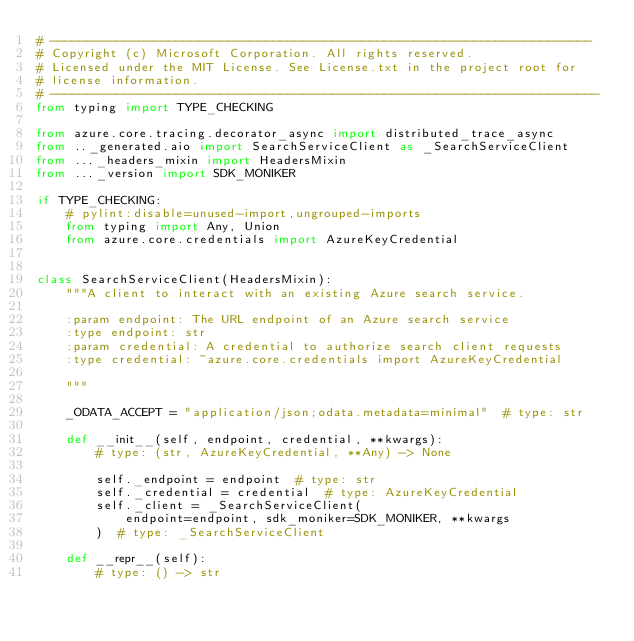<code> <loc_0><loc_0><loc_500><loc_500><_Python_># -------------------------------------------------------------------------
# Copyright (c) Microsoft Corporation. All rights reserved.
# Licensed under the MIT License. See License.txt in the project root for
# license information.
# --------------------------------------------------------------------------
from typing import TYPE_CHECKING

from azure.core.tracing.decorator_async import distributed_trace_async
from .._generated.aio import SearchServiceClient as _SearchServiceClient
from ..._headers_mixin import HeadersMixin
from ..._version import SDK_MONIKER

if TYPE_CHECKING:
    # pylint:disable=unused-import,ungrouped-imports
    from typing import Any, Union
    from azure.core.credentials import AzureKeyCredential


class SearchServiceClient(HeadersMixin):
    """A client to interact with an existing Azure search service.

    :param endpoint: The URL endpoint of an Azure search service
    :type endpoint: str
    :param credential: A credential to authorize search client requests
    :type credential: ~azure.core.credentials import AzureKeyCredential

    """

    _ODATA_ACCEPT = "application/json;odata.metadata=minimal"  # type: str

    def __init__(self, endpoint, credential, **kwargs):
        # type: (str, AzureKeyCredential, **Any) -> None

        self._endpoint = endpoint  # type: str
        self._credential = credential  # type: AzureKeyCredential
        self._client = _SearchServiceClient(
            endpoint=endpoint, sdk_moniker=SDK_MONIKER, **kwargs
        )  # type: _SearchServiceClient

    def __repr__(self):
        # type: () -> str</code> 